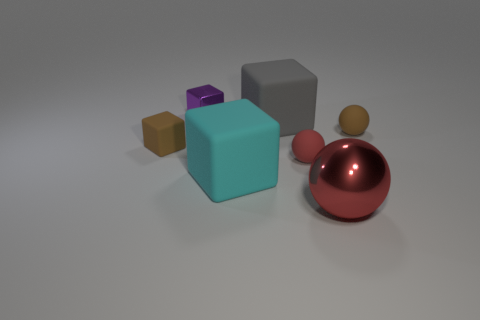Add 3 large gray rubber things. How many objects exist? 10 Subtract all blocks. How many objects are left? 3 Add 3 purple things. How many purple things are left? 4 Add 1 tiny yellow metal objects. How many tiny yellow metal objects exist? 1 Subtract 0 blue cylinders. How many objects are left? 7 Subtract all brown rubber objects. Subtract all blocks. How many objects are left? 1 